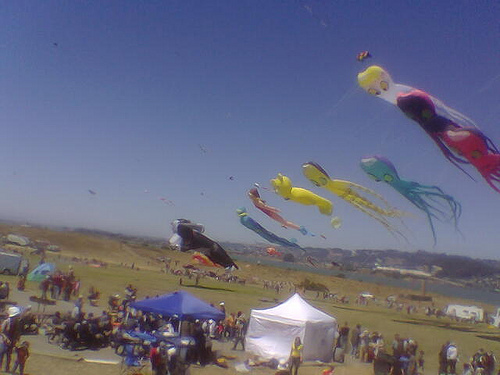What type of structures are shown?
A. garage
B. home
C. tent
D. hotel
Answer with the option's letter from the given choices directly. The correct answer is C. The structures shown in the image are tents, typically used at events or as temporary shelter outdoors, as evidenced by their size, shape, and the context of the setting, which appears to be an outdoor festival or gathering with kites flying in the background. 